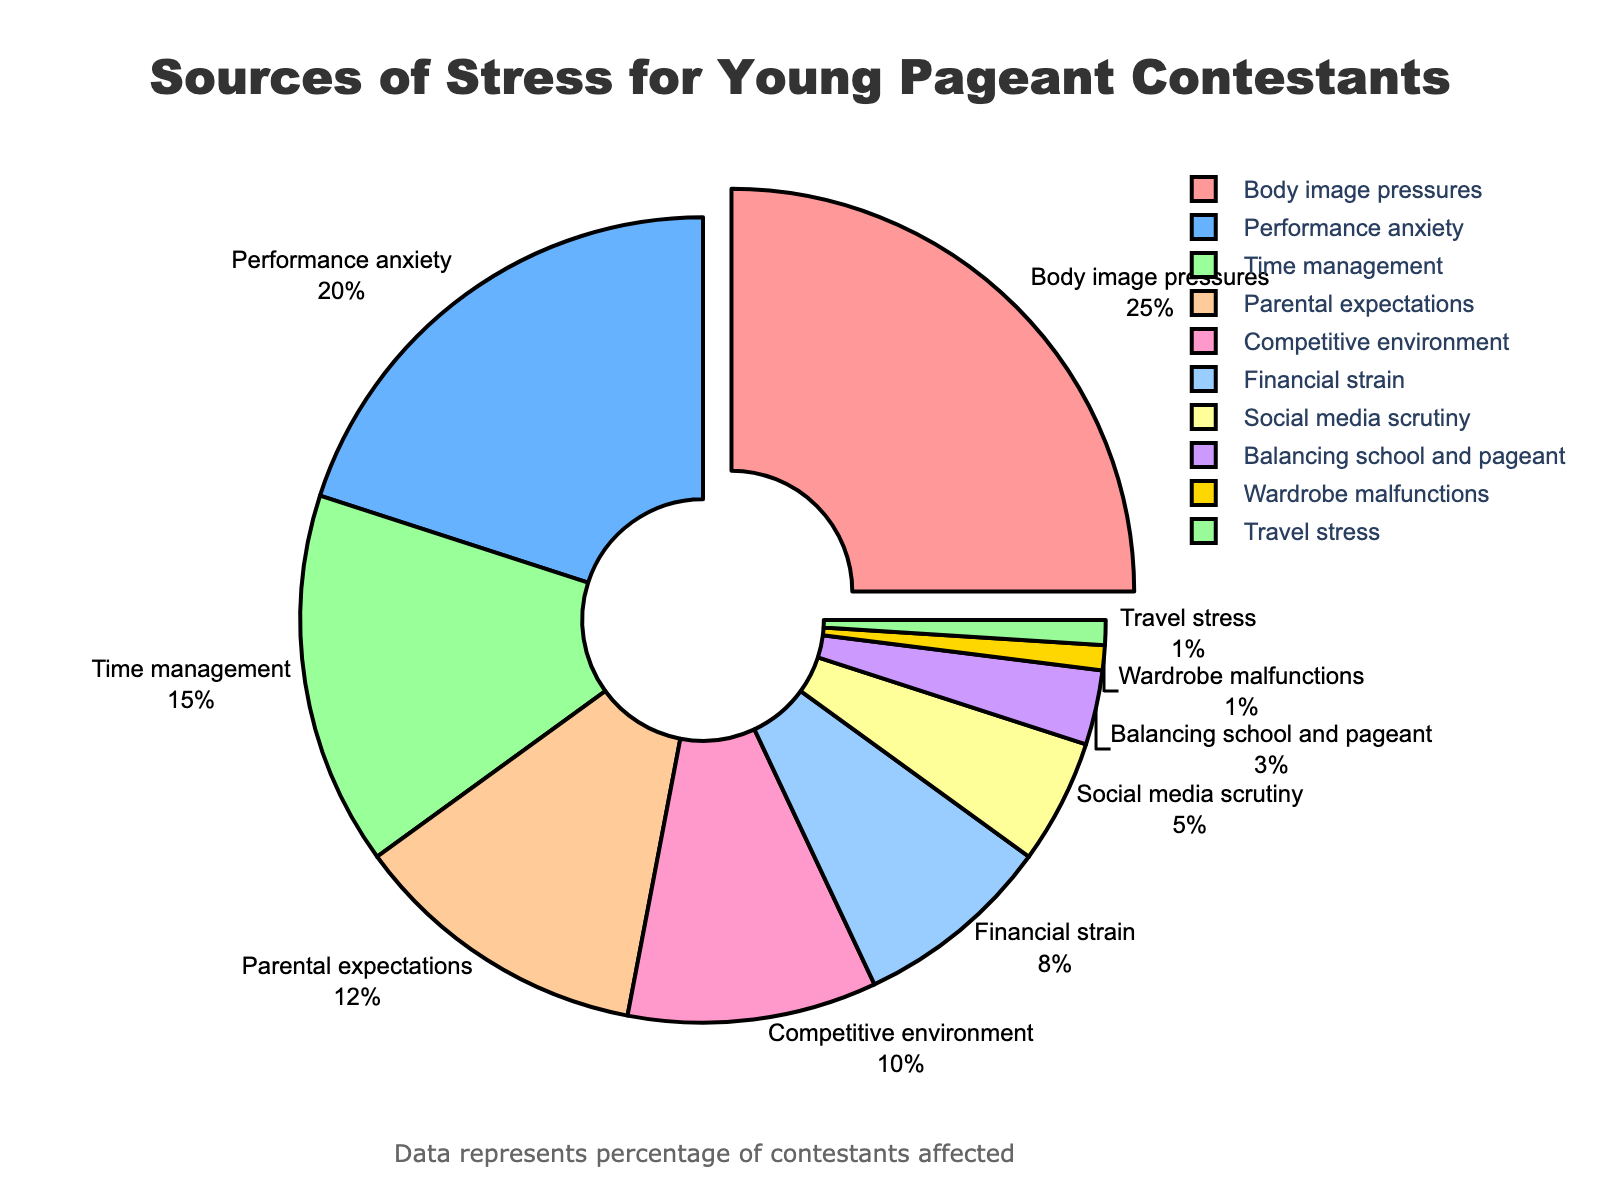Which category is the largest source of stress for young pageant contestants? The largest percentage in the figure corresponds to the "Body image pressures" category, which has a 25% slice.
Answer: Body image pressures What is the total percentage of stress caused by "Body image pressures" and "Performance anxiety"? To find the total percentage, add the percentages of "Body image pressures" (25%) and "Performance anxiety" (20%). So, 25% + 20% = 45%.
Answer: 45% Which source of stress is represented by the color light blue? The color light blue represents "Performance anxiety," based on its position in the legend of the figure.
Answer: Performance anxiety Compare "Parental expectations" and "Financial strain" in terms of their contribution to stress. Which one is higher and by how much? "Parental expectations" has a percentage of 12%, while "Financial strain" has 8%. The difference between the two is 12% - 8% = 4%. Therefore, "Parental expectations" is higher by 4%.
Answer: Parental expectations, by 4% Which sources of stress contribute to less than 10% each? The sources of stress that contribute less than 10% each are "Financial strain" (8%), "Social media scrutiny" (5%), "Balancing school and pageant" (3%), "Wardrobe malfunctions" (1%), and "Travel stress" (1%).
Answer: Financial strain, Social media scrutiny, Balancing school and pageant, Wardrobe malfunctions, Travel stress What percentage of stress sources could be attributed to environmental factors (Competitive environment and Travel stress)? Add the percentages for "Competitive environment" (10%) and "Travel stress" (1%). So, 10% + 1% = 11%.
Answer: 11% How does the percentage of "Time management" compare to that of "Performance anxiety"? "Time management" has a percentage of 15%, while "Performance anxiety" has 20%. Thus, "Performance anxiety" is higher by 5% (20% - 15%).
Answer: Performance anxiety is higher by 5% Which category has the smallest source of stress, and what is the exact percentage? The smallest source of stress is tied between "Wardrobe malfunctions" and "Travel stress," both at 1%.
Answer: Wardrobe malfunctions, Travel stress, 1% 